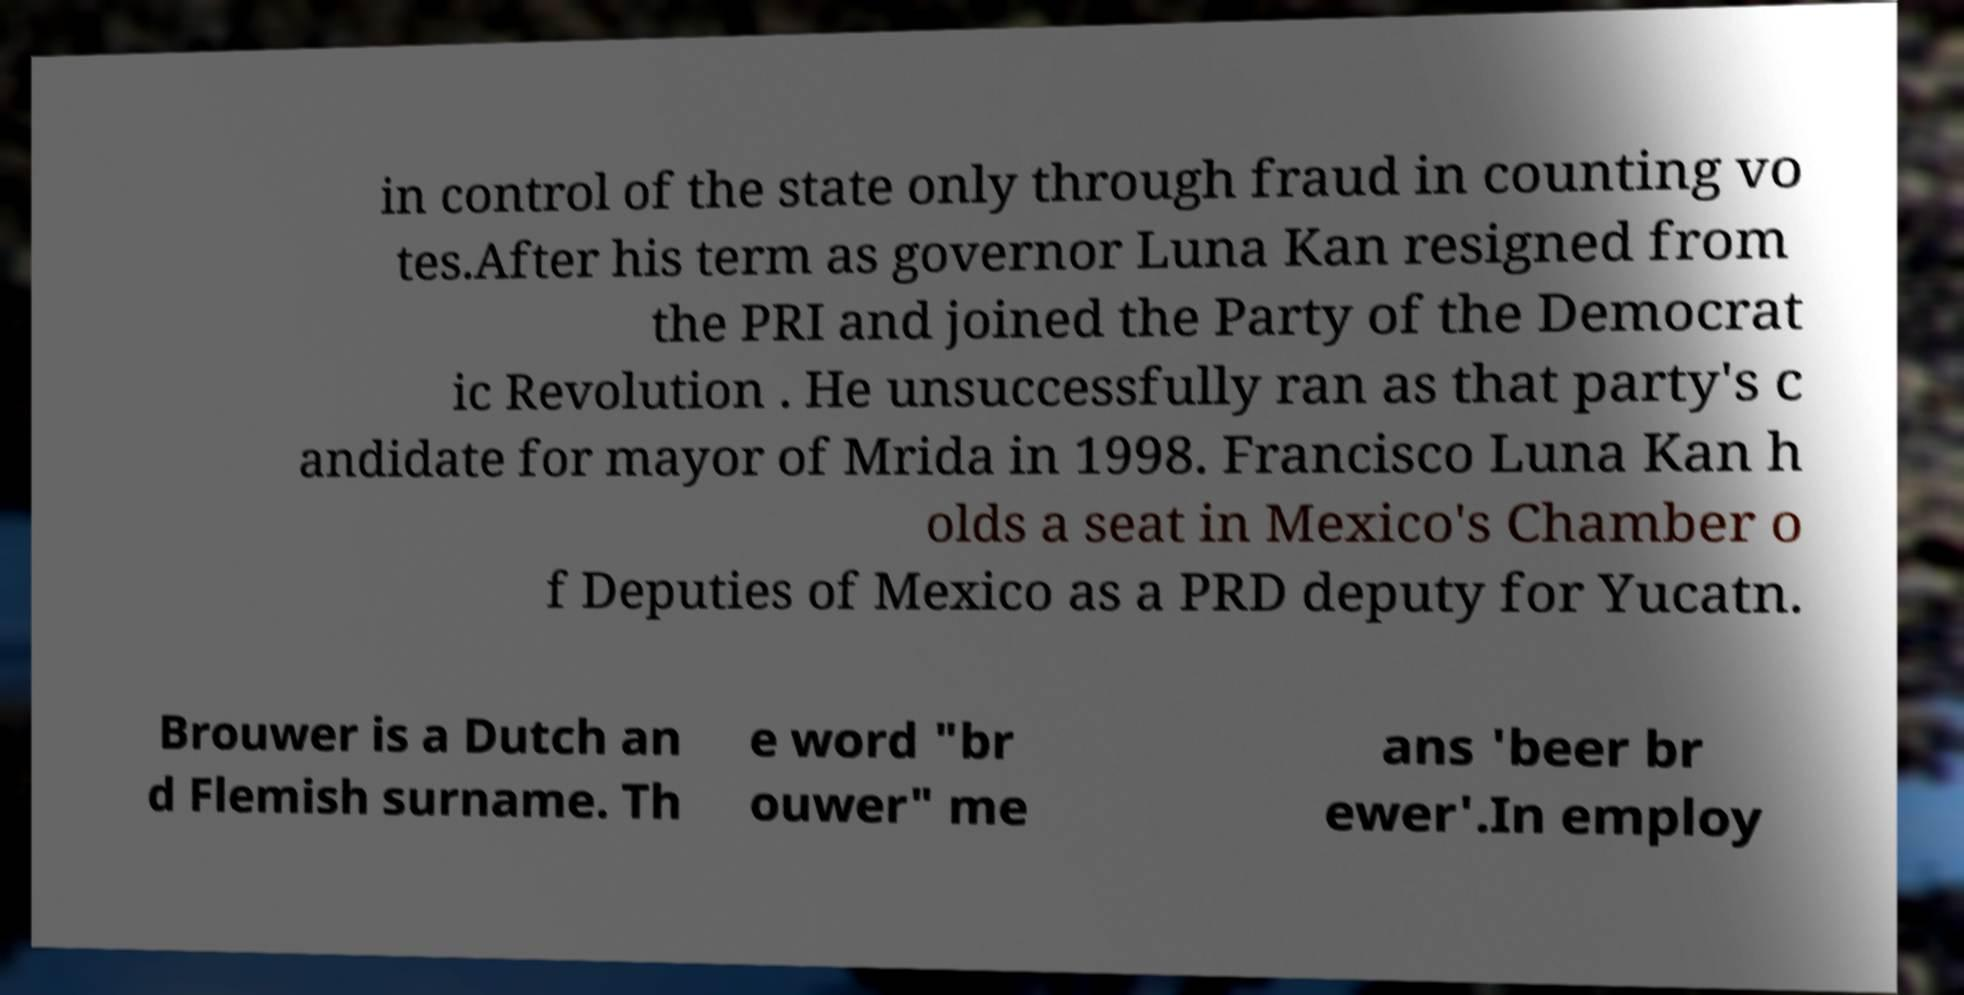Can you accurately transcribe the text from the provided image for me? in control of the state only through fraud in counting vo tes.After his term as governor Luna Kan resigned from the PRI and joined the Party of the Democrat ic Revolution . He unsuccessfully ran as that party's c andidate for mayor of Mrida in 1998. Francisco Luna Kan h olds a seat in Mexico's Chamber o f Deputies of Mexico as a PRD deputy for Yucatn. Brouwer is a Dutch an d Flemish surname. Th e word "br ouwer" me ans 'beer br ewer'.In employ 